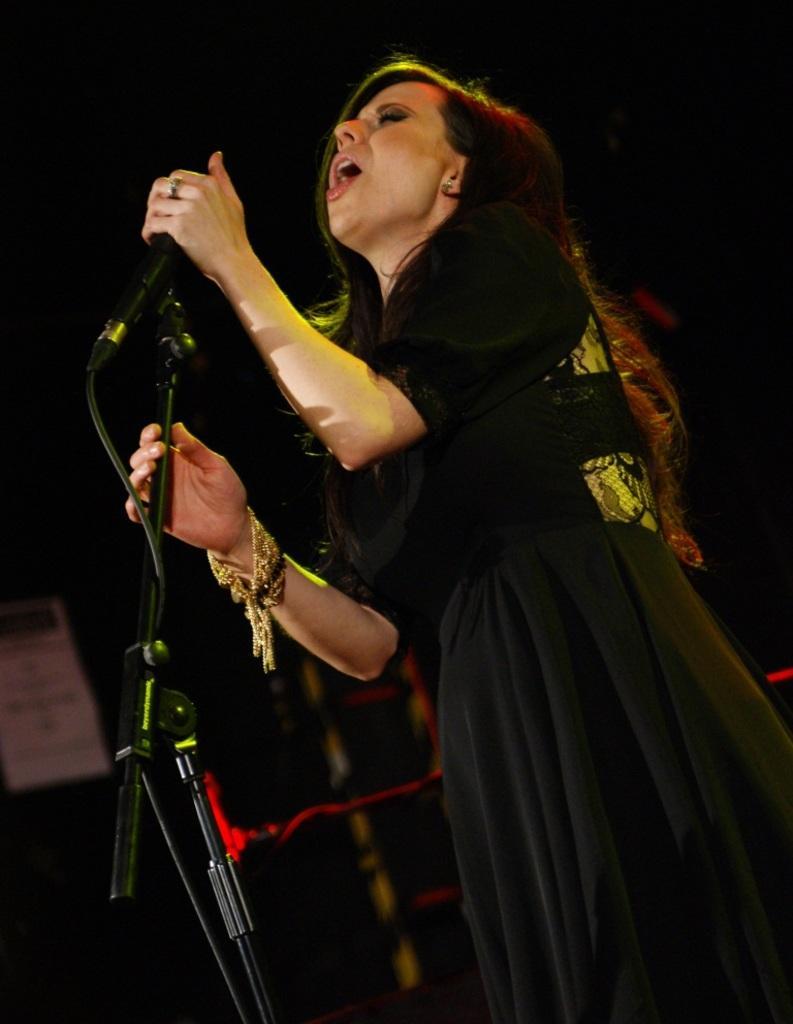Can you describe this image briefly? In this image I can see a woman is singing a song by holding a mike in her hand. 